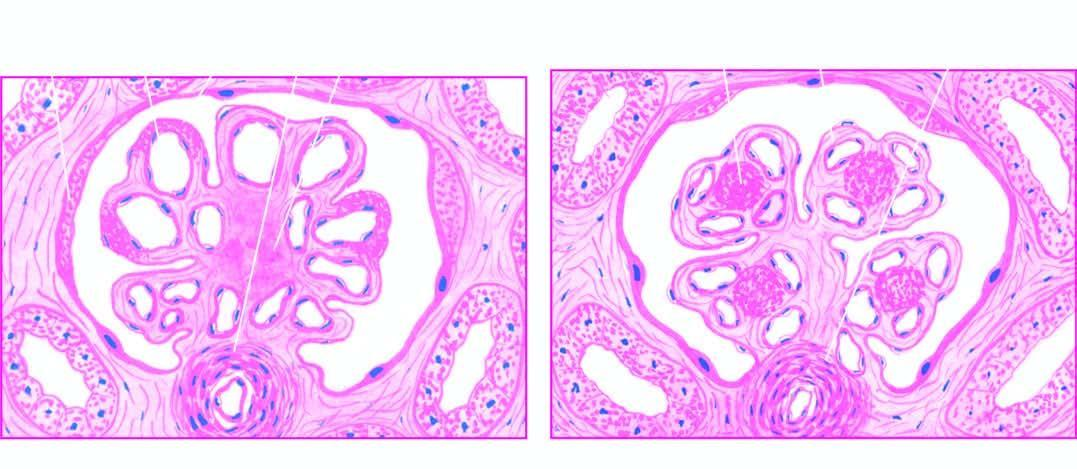what are diffuse involvement of the glomeruli showing thickening of the gbm and diffuse increase in the mesangial matrix with mild proliferation of mesangial cells and exudative lesions fibrin caps and capsular drops?
Answer the question using a single word or phrase. Characteristic features 